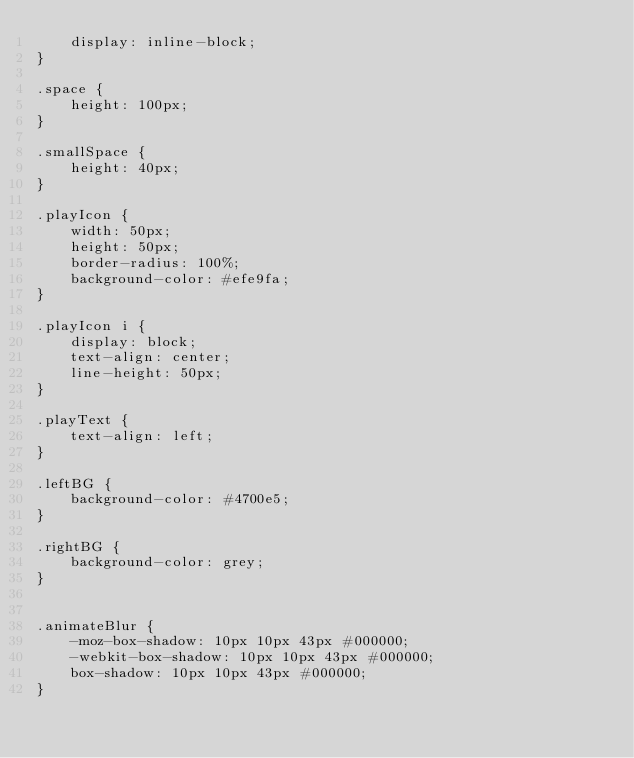Convert code to text. <code><loc_0><loc_0><loc_500><loc_500><_CSS_>    display: inline-block;
}

.space {
    height: 100px;
}

.smallSpace {
    height: 40px;
}

.playIcon {
    width: 50px;
    height: 50px;
    border-radius: 100%;
    background-color: #efe9fa;
}

.playIcon i {
    display: block;
    text-align: center;
    line-height: 50px;
}

.playText {
    text-align: left;
}

.leftBG {
    background-color: #4700e5;
}

.rightBG {
    background-color: grey;
}


.animateBlur {
    -moz-box-shadow: 10px 10px 43px #000000;
    -webkit-box-shadow: 10px 10px 43px #000000;
    box-shadow: 10px 10px 43px #000000;
}

</code> 